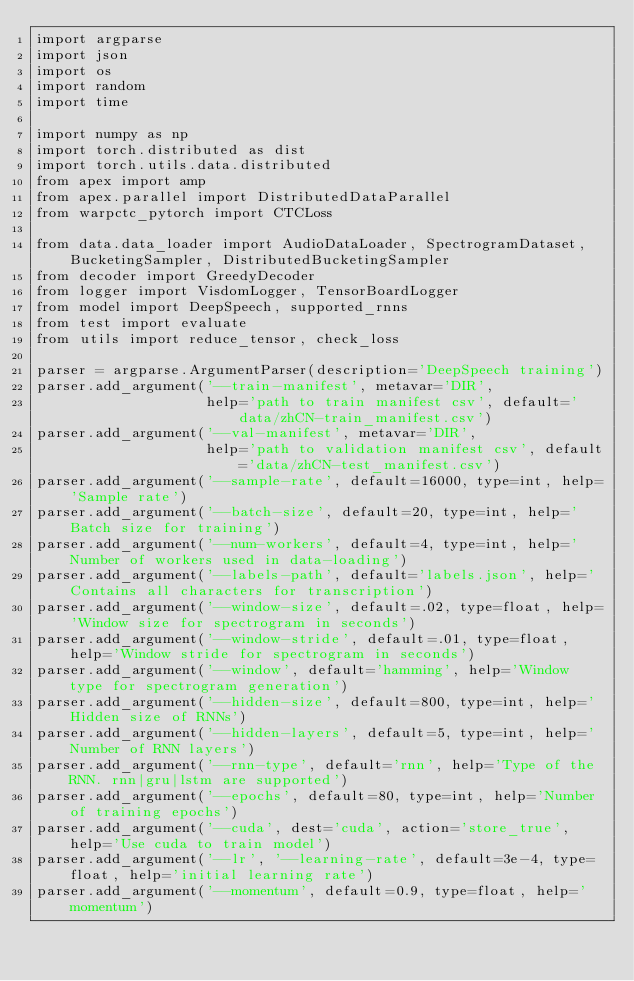Convert code to text. <code><loc_0><loc_0><loc_500><loc_500><_Python_>import argparse
import json
import os
import random
import time

import numpy as np
import torch.distributed as dist
import torch.utils.data.distributed
from apex import amp
from apex.parallel import DistributedDataParallel
from warpctc_pytorch import CTCLoss

from data.data_loader import AudioDataLoader, SpectrogramDataset, BucketingSampler, DistributedBucketingSampler
from decoder import GreedyDecoder
from logger import VisdomLogger, TensorBoardLogger
from model import DeepSpeech, supported_rnns
from test import evaluate
from utils import reduce_tensor, check_loss

parser = argparse.ArgumentParser(description='DeepSpeech training')
parser.add_argument('--train-manifest', metavar='DIR',
                    help='path to train manifest csv', default='data/zhCN-train_manifest.csv')
parser.add_argument('--val-manifest', metavar='DIR',
                    help='path to validation manifest csv', default='data/zhCN-test_manifest.csv')
parser.add_argument('--sample-rate', default=16000, type=int, help='Sample rate')
parser.add_argument('--batch-size', default=20, type=int, help='Batch size for training')
parser.add_argument('--num-workers', default=4, type=int, help='Number of workers used in data-loading')
parser.add_argument('--labels-path', default='labels.json', help='Contains all characters for transcription')
parser.add_argument('--window-size', default=.02, type=float, help='Window size for spectrogram in seconds')
parser.add_argument('--window-stride', default=.01, type=float, help='Window stride for spectrogram in seconds')
parser.add_argument('--window', default='hamming', help='Window type for spectrogram generation')
parser.add_argument('--hidden-size', default=800, type=int, help='Hidden size of RNNs')
parser.add_argument('--hidden-layers', default=5, type=int, help='Number of RNN layers')
parser.add_argument('--rnn-type', default='rnn', help='Type of the RNN. rnn|gru|lstm are supported')
parser.add_argument('--epochs', default=80, type=int, help='Number of training epochs')
parser.add_argument('--cuda', dest='cuda', action='store_true', help='Use cuda to train model')
parser.add_argument('--lr', '--learning-rate', default=3e-4, type=float, help='initial learning rate')
parser.add_argument('--momentum', default=0.9, type=float, help='momentum')</code> 